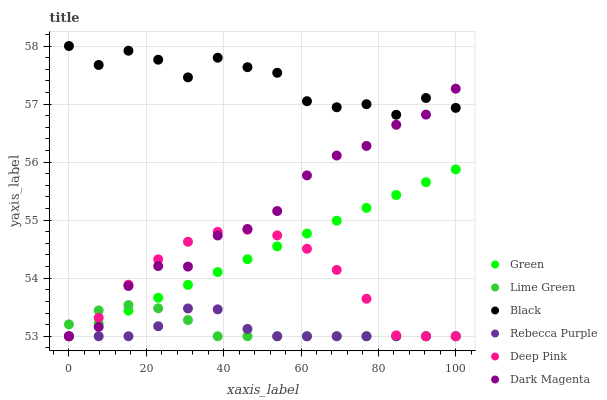Does Rebecca Purple have the minimum area under the curve?
Answer yes or no. Yes. Does Black have the maximum area under the curve?
Answer yes or no. Yes. Does Dark Magenta have the minimum area under the curve?
Answer yes or no. No. Does Dark Magenta have the maximum area under the curve?
Answer yes or no. No. Is Green the smoothest?
Answer yes or no. Yes. Is Black the roughest?
Answer yes or no. Yes. Is Dark Magenta the smoothest?
Answer yes or no. No. Is Dark Magenta the roughest?
Answer yes or no. No. Does Deep Pink have the lowest value?
Answer yes or no. Yes. Does Black have the lowest value?
Answer yes or no. No. Does Black have the highest value?
Answer yes or no. Yes. Does Dark Magenta have the highest value?
Answer yes or no. No. Is Green less than Black?
Answer yes or no. Yes. Is Black greater than Green?
Answer yes or no. Yes. Does Deep Pink intersect Green?
Answer yes or no. Yes. Is Deep Pink less than Green?
Answer yes or no. No. Is Deep Pink greater than Green?
Answer yes or no. No. Does Green intersect Black?
Answer yes or no. No. 